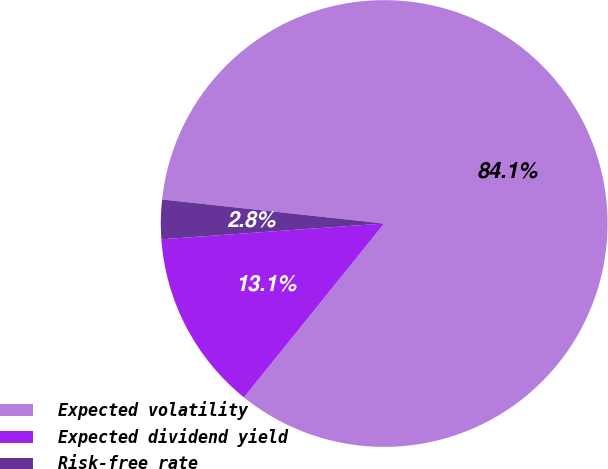Convert chart. <chart><loc_0><loc_0><loc_500><loc_500><pie_chart><fcel>Expected volatility<fcel>Expected dividend yield<fcel>Risk-free rate<nl><fcel>84.09%<fcel>13.07%<fcel>2.84%<nl></chart> 